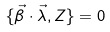Convert formula to latex. <formula><loc_0><loc_0><loc_500><loc_500>\{ \vec { \beta } \cdot \vec { \lambda } , Z \} = 0</formula> 